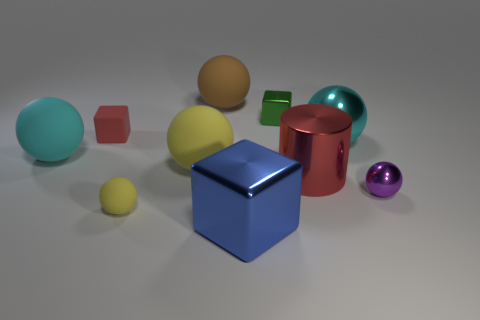Subtract all brown balls. How many balls are left? 5 Subtract all large metallic spheres. How many spheres are left? 5 Subtract all blue spheres. Subtract all red cylinders. How many spheres are left? 6 Subtract all cubes. How many objects are left? 7 Subtract 1 purple spheres. How many objects are left? 9 Subtract all large objects. Subtract all small metal things. How many objects are left? 2 Add 5 metal balls. How many metal balls are left? 7 Add 1 big yellow cubes. How many big yellow cubes exist? 1 